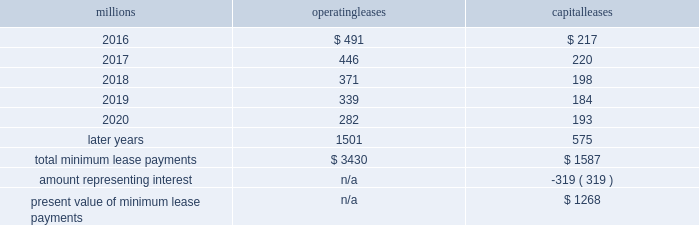We maintain and operate the assets based on contractual obligations within the lease arrangements , which set specific guidelines consistent within the railroad industry .
As such , we have no control over activities that could materially impact the fair value of the leased assets .
We do not hold the power to direct the activities of the vies and , therefore , do not control the ongoing activities that have a significant impact on the economic performance of the vies .
Additionally , we do not have the obligation to absorb losses of the vies or the right to receive benefits of the vies that could potentially be significant to the we are not considered to be the primary beneficiary and do not consolidate these vies because our actions and decisions do not have the most significant effect on the vie 2019s performance and our fixed-price purchase options are not considered to be potentially significant to the vies .
The future minimum lease payments associated with the vie leases totaled $ 2.6 billion as of december 31 , 2015 .
17 .
Leases we lease certain locomotives , freight cars , and other property .
The consolidated statements of financial position as of december 31 , 2015 and 2014 included $ 2273 million , net of $ 1189 million of accumulated depreciation , and $ 2454 million , net of $ 1210 million of accumulated depreciation , respectively , for properties held under capital leases .
A charge to income resulting from the depreciation for assets held under capital leases is included within depreciation expense in our consolidated statements of income .
Future minimum lease payments for operating and capital leases with initial or remaining non-cancelable lease terms in excess of one year as of december 31 , 2015 , were as follows : millions operating leases capital leases .
Approximately 95% ( 95 % ) of capital lease payments relate to locomotives .
Rent expense for operating leases with terms exceeding one month was $ 590 million in 2015 , $ 593 million in 2014 , and $ 618 million in 2013 .
When cash rental payments are not made on a straight-line basis , we recognize variable rental expense on a straight-line basis over the lease term .
Contingent rentals and sub-rentals are not significant .
18 .
Commitments and contingencies asserted and unasserted claims 2013 various claims and lawsuits are pending against us and certain of our subsidiaries .
We cannot fully determine the effect of all asserted and unasserted claims on our consolidated results of operations , financial condition , or liquidity .
To the extent possible , we have recorded a liability where asserted and unasserted claims are considered probable and where such claims can be reasonably estimated .
We do not expect that any known lawsuits , claims , environmental costs , commitments , contingent liabilities , or guarantees will have a material adverse effect on our consolidated results of operations , financial condition , or liquidity after taking into account liabilities and insurance recoveries previously recorded for these matters .
Personal injury 2013 the cost of personal injuries to employees and others related to our activities is charged to expense based on estimates of the ultimate cost and number of incidents each year .
We use an actuarial analysis to measure the expense and liability , including unasserted claims .
The federal employers 2019 liability act ( fela ) governs compensation for work-related accidents .
Under fela , damages are assessed based on a finding of fault through litigation or out-of-court settlements .
We offer a comprehensive variety of services and rehabilitation programs for employees who are injured at work .
Our personal injury liability is not discounted to present value due to the uncertainty surrounding the timing of future payments .
Approximately 94% ( 94 % ) of the recorded liability is related to asserted claims and .
What percentage of total minimum lease payments are operating leases leases? 
Computations: (3430 / (3430 + 1587))
Answer: 0.68368. 